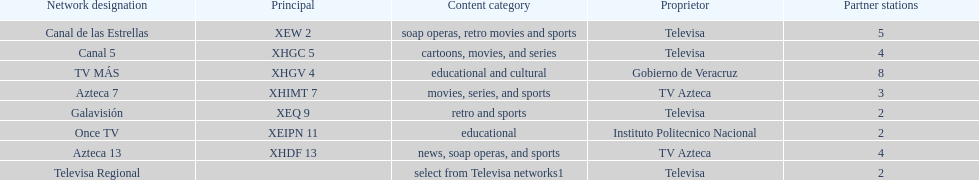How many networks show soap operas? 2. 